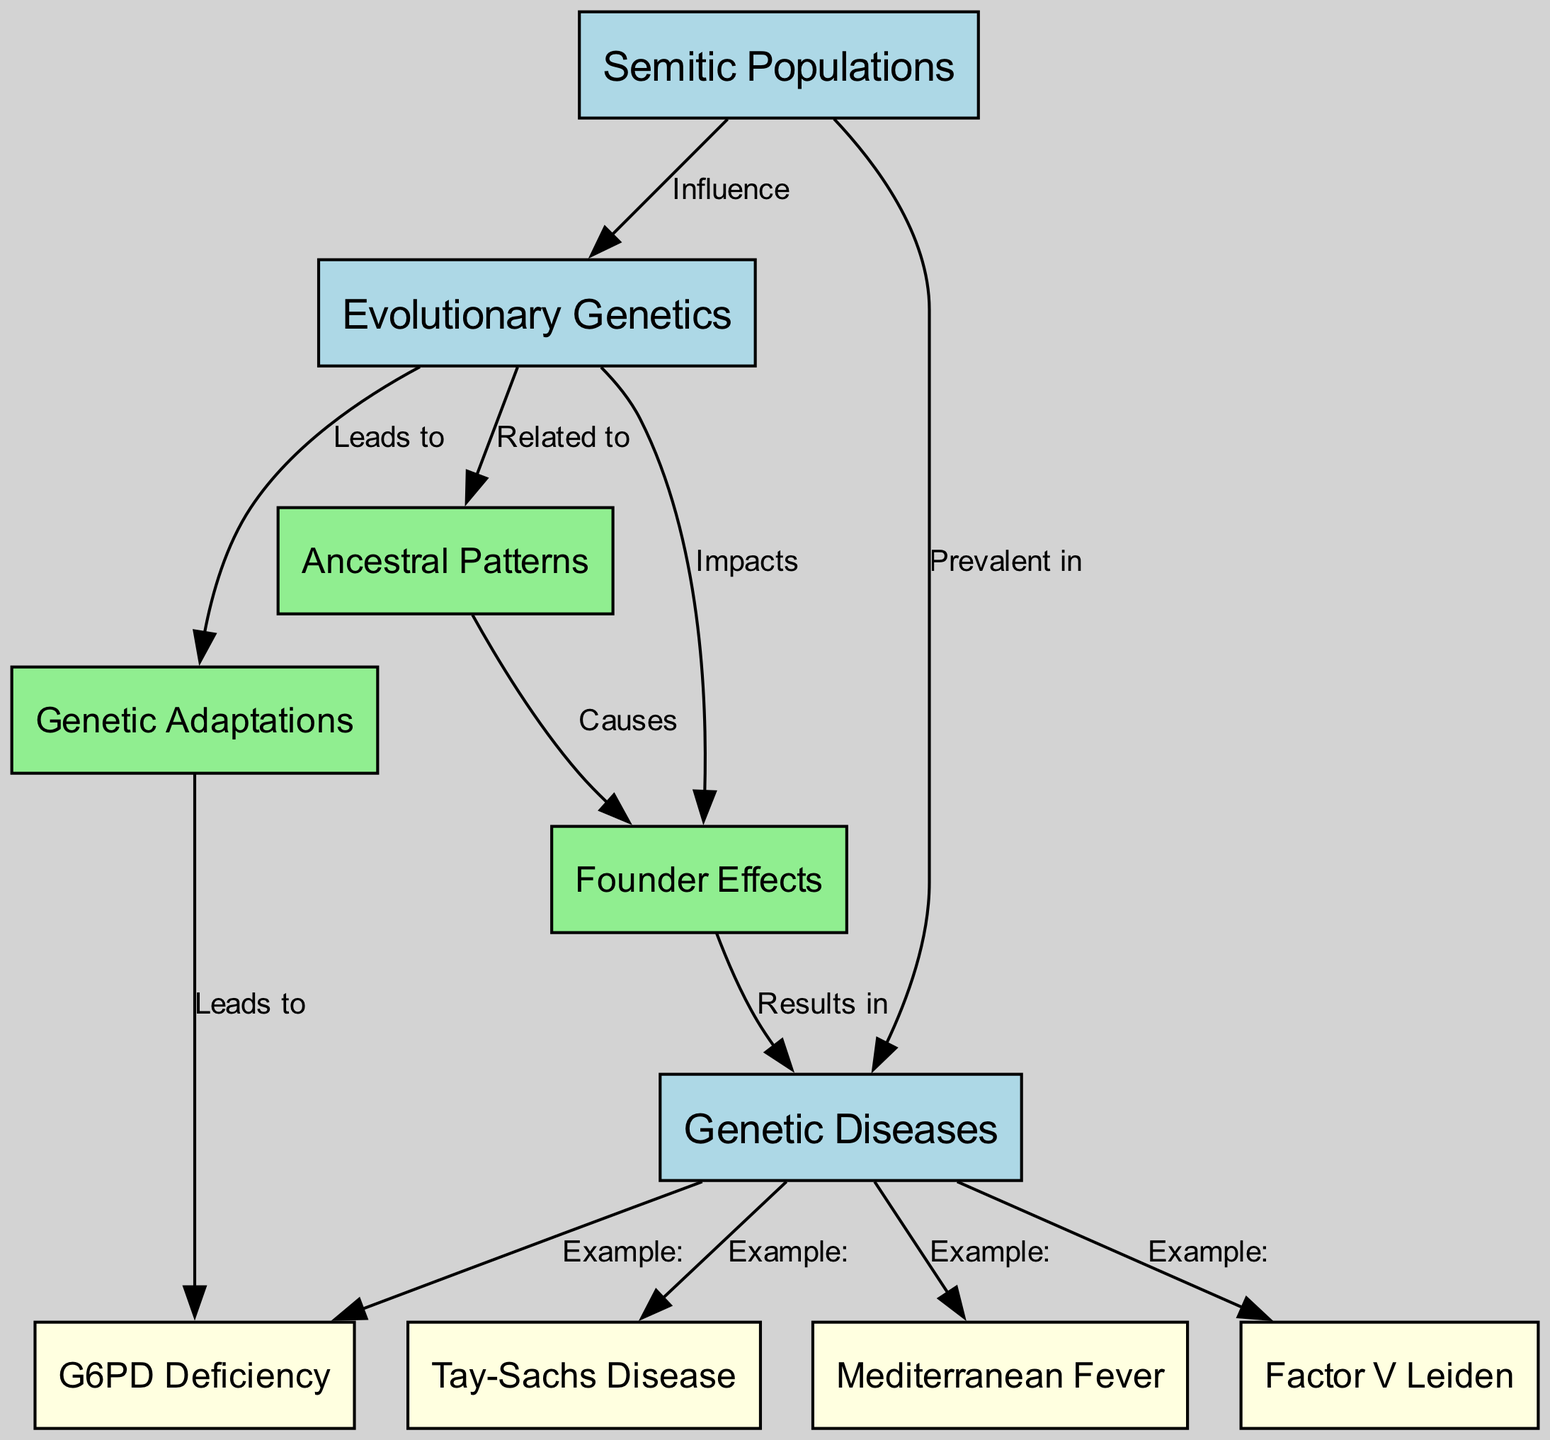What node represents genetic diseases? In the diagram, the node labeled "Genetic Diseases" corresponds to the id "gen_dis". This node connects to examples of specific diseases prevalent in Semitic populations, highlighting its importance.
Answer: Genetic Diseases How many examples of genetic diseases are listed in the diagram? The diagram shows four examples of genetic diseases that connect to the "Genetic Diseases" node: Factor V Leiden, G6PD Deficiency, Tay-Sachs Disease, and Mediterranean Fever. Counting these gives a total of four.
Answer: 4 What influences the Semitic populations regarding medical conditions? The diagram indicates that "Evolutionary Genetics" has an influence on "Semitic Populations". This relationship suggests that the evolutionary genetic factors are significant in understanding the medical conditions prevalent in these populations.
Answer: Evolutionary Genetics What causes founder effects in Semitic populations? According to the diagram, "Ancestral Patterns" are shown to cause "Founder Effects." This suggests that the genetic ancestry of these populations contributes to specific genetic variations or diseases.
Answer: Ancestral Patterns What leads to G6PD Deficiency? The diagram shows that "Genetic Adaptations" lead to "G6PD Deficiency". This means that adaptations related to genetics can result in this specific deficiency in Semitic populations.
Answer: Genetic Adaptations Which disease is an example of a genetic disease prevalent in Semitic populations? The diagram provides multiple examples. One clear example, indicated by the edge labeled "Example:", is "Tay-Sachs Disease". This connects directly to the "Genetic Diseases" node.
Answer: Tay-Sachs Disease How do founder effects impact genetic diseases? The diagram connects "Founder Effects" to "Genetic Diseases" with an edge labeled "Results in". This means that the occurrence of founder effects can directly lead to the prevalence of certain genetic diseases in Semitic populations.
Answer: Results in What is related to evolutionary genetics? The diagram shows that "Ancestral Patterns" are related to "Evolutionary Genetics". This connection implies that the ancestry of a population plays a crucial role in their evolutionary genetic traits.
Answer: Ancestral Patterns 